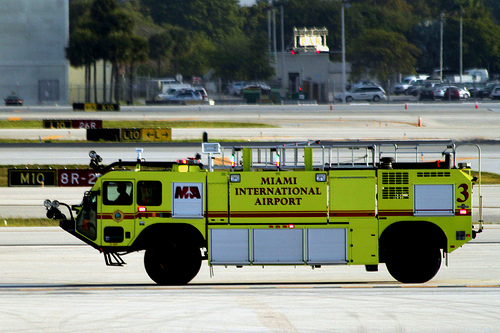<image>
Is there a vehicle behind the wheel? No. The vehicle is not behind the wheel. From this viewpoint, the vehicle appears to be positioned elsewhere in the scene. 